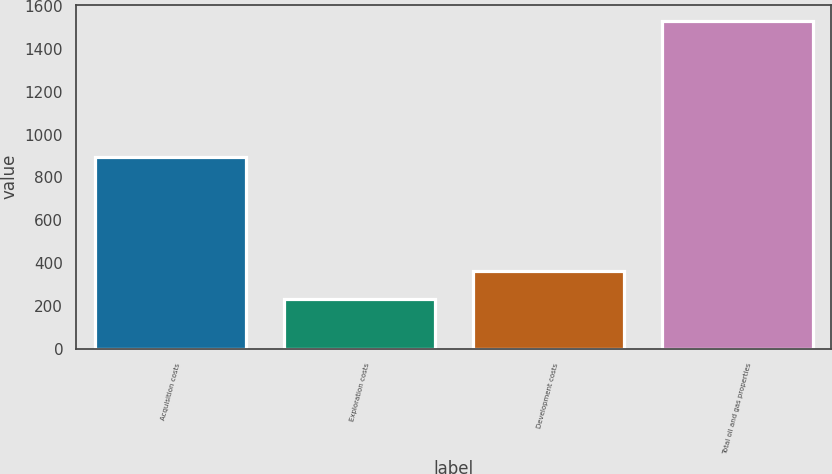Convert chart. <chart><loc_0><loc_0><loc_500><loc_500><bar_chart><fcel>Acquisition costs<fcel>Exploration costs<fcel>Development costs<fcel>Total oil and gas properties<nl><fcel>894<fcel>234<fcel>363.6<fcel>1530<nl></chart> 